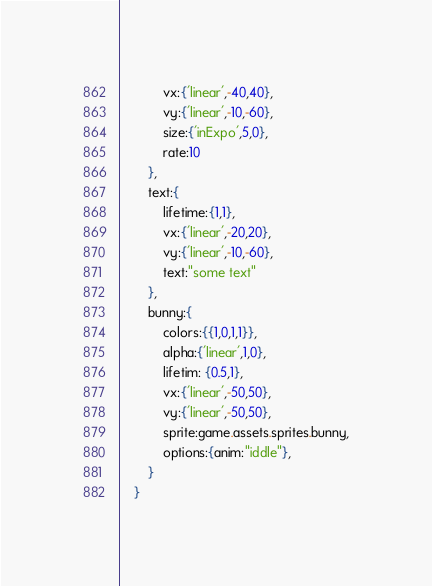<code> <loc_0><loc_0><loc_500><loc_500><_MoonScript_>			vx:{'linear',-40,40},
			vy:{'linear',-10,-60},
			size:{'inExpo',5,0},
			rate:10
		},
		text:{
			lifetime:{1,1},
			vx:{'linear',-20,20},
			vy:{'linear',-10,-60},
			text:"some text"
		},
		bunny:{
			colors:{{1,0,1,1}},
			alpha:{'linear',1,0},
			lifetim: {0.5,1},
			vx:{'linear',-50,50},
			vy:{'linear',-50,50},
			sprite:game.assets.sprites.bunny,
			options:{anim:"iddle"},
		}
	}
</code> 